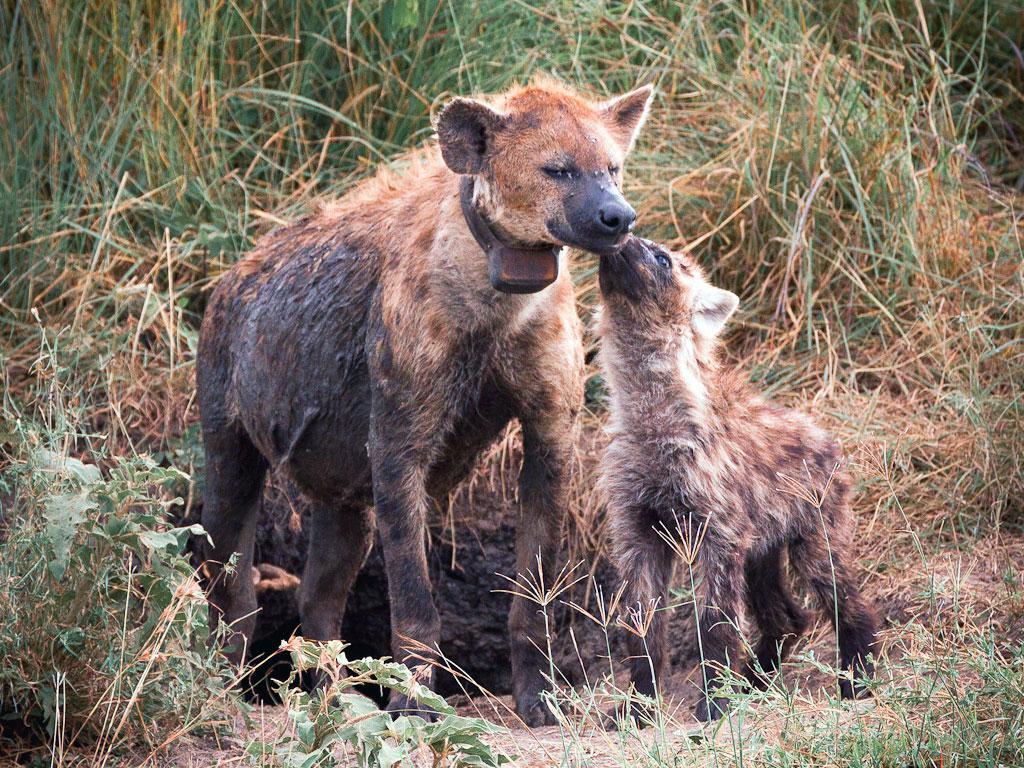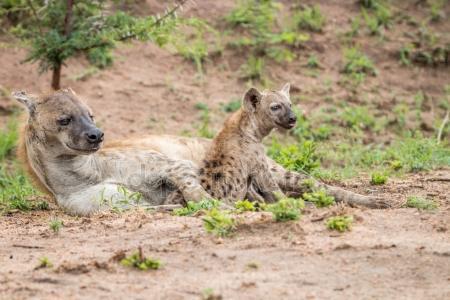The first image is the image on the left, the second image is the image on the right. For the images shown, is this caption "There are exactly four hyenas." true? Answer yes or no. Yes. The first image is the image on the left, the second image is the image on the right. For the images displayed, is the sentence "The right image has two hyenas laying on the ground" factually correct? Answer yes or no. Yes. 